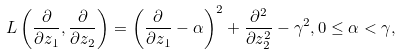Convert formula to latex. <formula><loc_0><loc_0><loc_500><loc_500>L \left ( \frac { \partial } { \partial z _ { 1 } } , \frac { \partial } { \partial z _ { 2 } } \right ) = \left ( \frac { \partial } { \partial z _ { 1 } } - \alpha \right ) ^ { 2 } + \frac { \partial ^ { 2 } } { \partial z _ { 2 } ^ { 2 } } - \gamma ^ { 2 } , 0 \leq \alpha < \gamma ,</formula> 